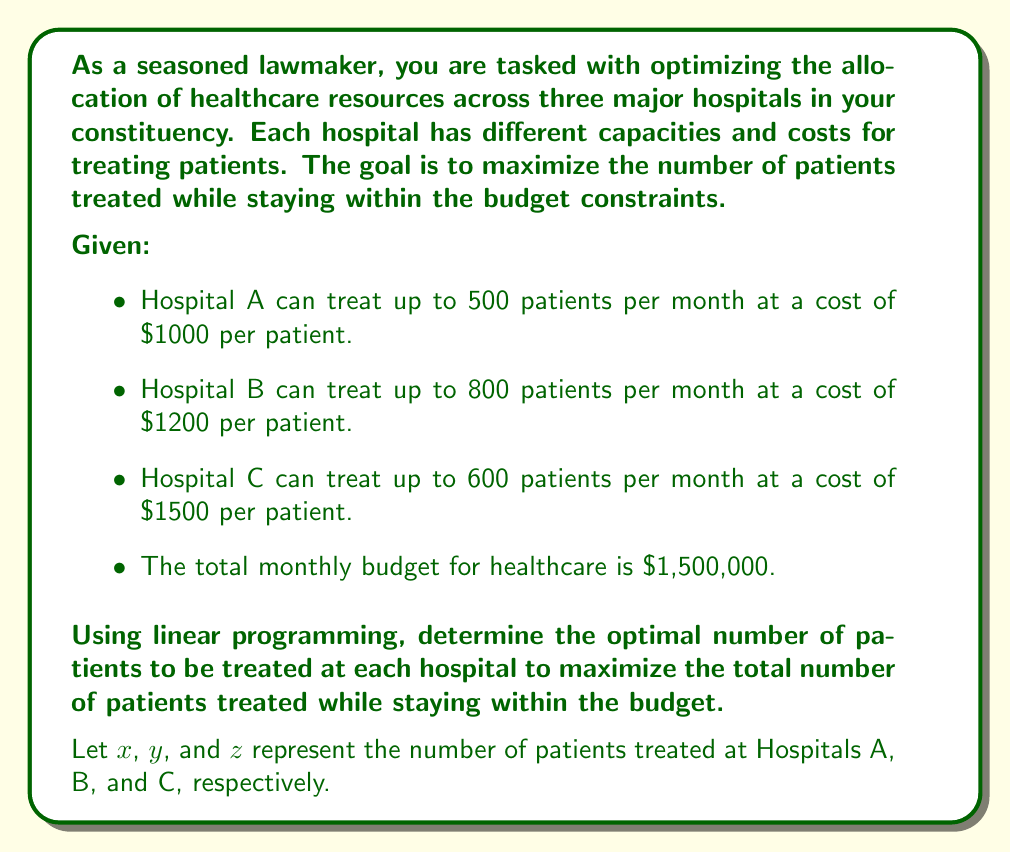Teach me how to tackle this problem. To solve this problem using linear programming, we need to formulate the objective function and constraints:

Objective function (maximize total patients treated):
$$\text{Maximize } f(x,y,z) = x + y + z$$

Constraints:
1. Capacity constraints:
   $$x \leq 500$$
   $$y \leq 800$$
   $$z \leq 600$$

2. Budget constraint:
   $$1000x + 1200y + 1500z \leq 1,500,000$$

3. Non-negativity constraints:
   $$x, y, z \geq 0$$

To solve this linear programming problem, we can use the simplex method or a linear programming solver. However, we can also reason through the solution:

1. Since we want to maximize the number of patients treated, we should prioritize hospitals with lower costs per patient.

2. Hospital A has the lowest cost per patient ($1000), so we should allocate the maximum capacity to Hospital A:
   $x = 500$

3. Hospital B has the second-lowest cost ($1200), so we should allocate as much as possible to Hospital B after Hospital A:
   $500 \times 1000 + 800 \times 1200 = 1,460,000$
   This is still within the budget, so $y = 800$

4. For Hospital C, we have $1,500,000 - 1,460,000 = 40,000$ left in the budget.
   We can treat $40,000 / 1500 = 26.67$ patients, but we need to round down to 26 patients.
   So, $z = 26$

5. Check if the solution satisfies all constraints:
   - Capacity constraints: $500 \leq 500$, $800 \leq 800$, $26 \leq 600$ (satisfied)
   - Budget constraint: $500 \times 1000 + 800 \times 1200 + 26 \times 1500 = 1,499,000 \leq 1,500,000$ (satisfied)
   - Non-negativity constraints: All values are positive (satisfied)

Therefore, the optimal solution is $x = 500$, $y = 800$, and $z = 26$.
Answer: The optimal allocation of patients to maximize the total number treated while staying within the budget is:
- Hospital A: 500 patients
- Hospital B: 800 patients
- Hospital C: 26 patients

Total patients treated: 1,326
Total cost: $1,499,000 